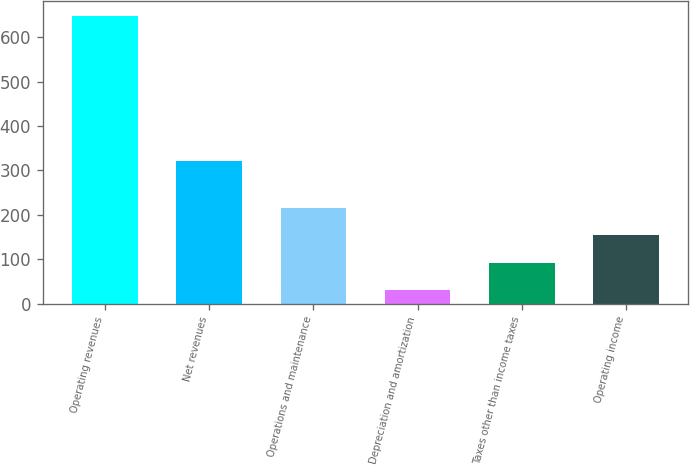Convert chart to OTSL. <chart><loc_0><loc_0><loc_500><loc_500><bar_chart><fcel>Operating revenues<fcel>Net revenues<fcel>Operations and maintenance<fcel>Depreciation and amortization<fcel>Taxes other than income taxes<fcel>Operating income<nl><fcel>648<fcel>320<fcel>215.4<fcel>30<fcel>91.8<fcel>153.6<nl></chart> 